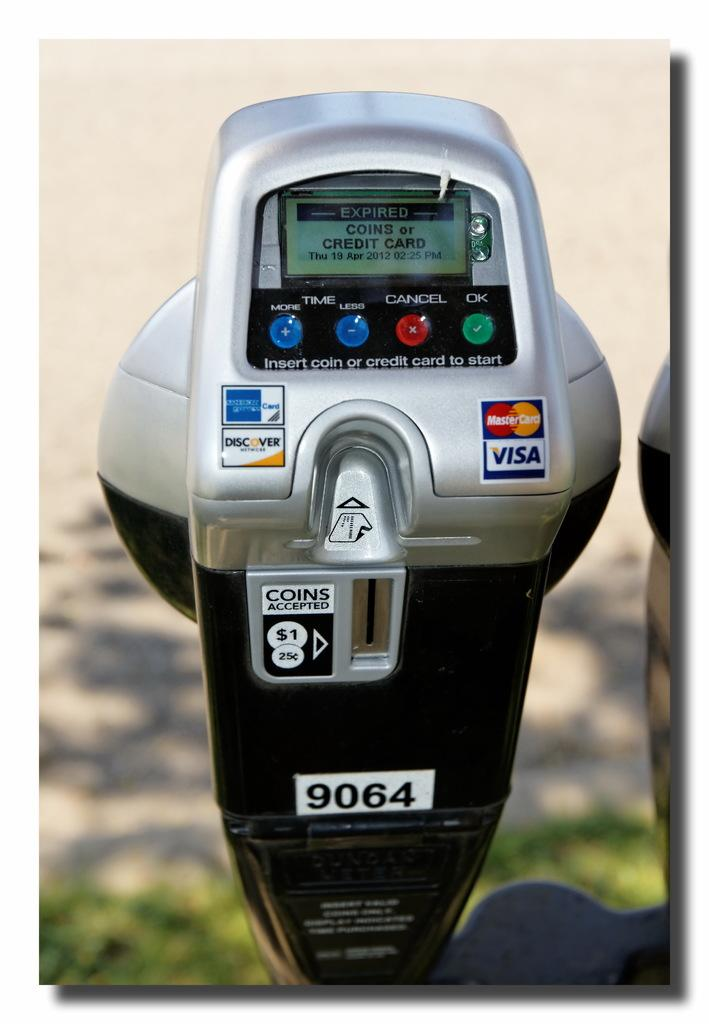<image>
Write a terse but informative summary of the picture. Parking meter that accepts coins outdoors on a sunny day. 